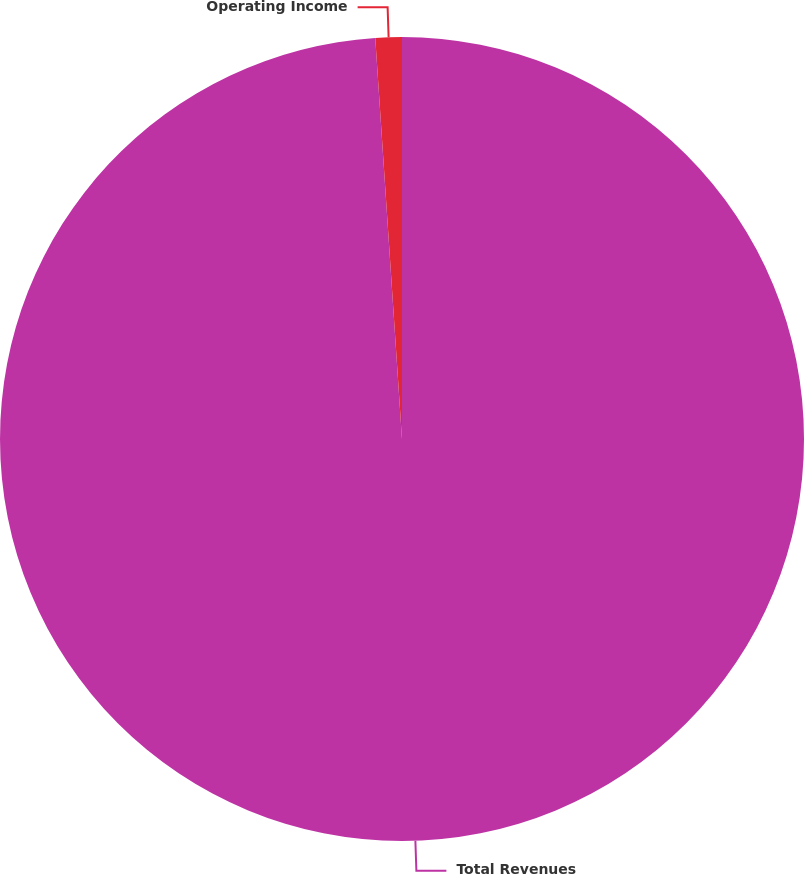Convert chart to OTSL. <chart><loc_0><loc_0><loc_500><loc_500><pie_chart><fcel>Total Revenues<fcel>Operating Income<nl><fcel>98.94%<fcel>1.06%<nl></chart> 